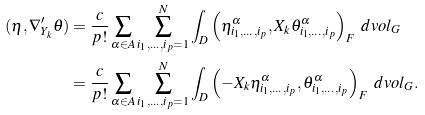<formula> <loc_0><loc_0><loc_500><loc_500>( \eta , \nabla ^ { \prime } _ { Y _ { k } } \theta ) & = \frac { c } { p ! } \sum _ { \alpha \in A } \sum _ { i _ { 1 } , \dots , i _ { p } = 1 } ^ { N } \int _ { D } \left ( \eta ^ { \alpha } _ { i _ { 1 } , \dots , i _ { p } } , X _ { k } \theta ^ { \alpha } _ { i _ { 1 } , \dots , i _ { p } } \right ) _ { F } \ d v o l _ { G } \\ & = \frac { c } { p ! } \sum _ { \alpha \in A } \sum _ { i _ { 1 } , \dots , i _ { p } = 1 } ^ { N } \int _ { D } \left ( - X _ { k } \eta ^ { \alpha } _ { i _ { 1 } , \dots , i _ { p } } , \theta ^ { \alpha } _ { i _ { 1 } , \dots , i _ { p } } \right ) _ { F } \ d v o l _ { G } .</formula> 